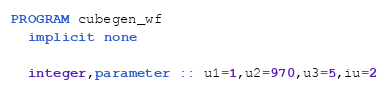<code> <loc_0><loc_0><loc_500><loc_500><_FORTRAN_>PROGRAM cubegen_wf
  implicit none

  integer,parameter :: u1=1,u2=970,u3=5,iu=2</code> 